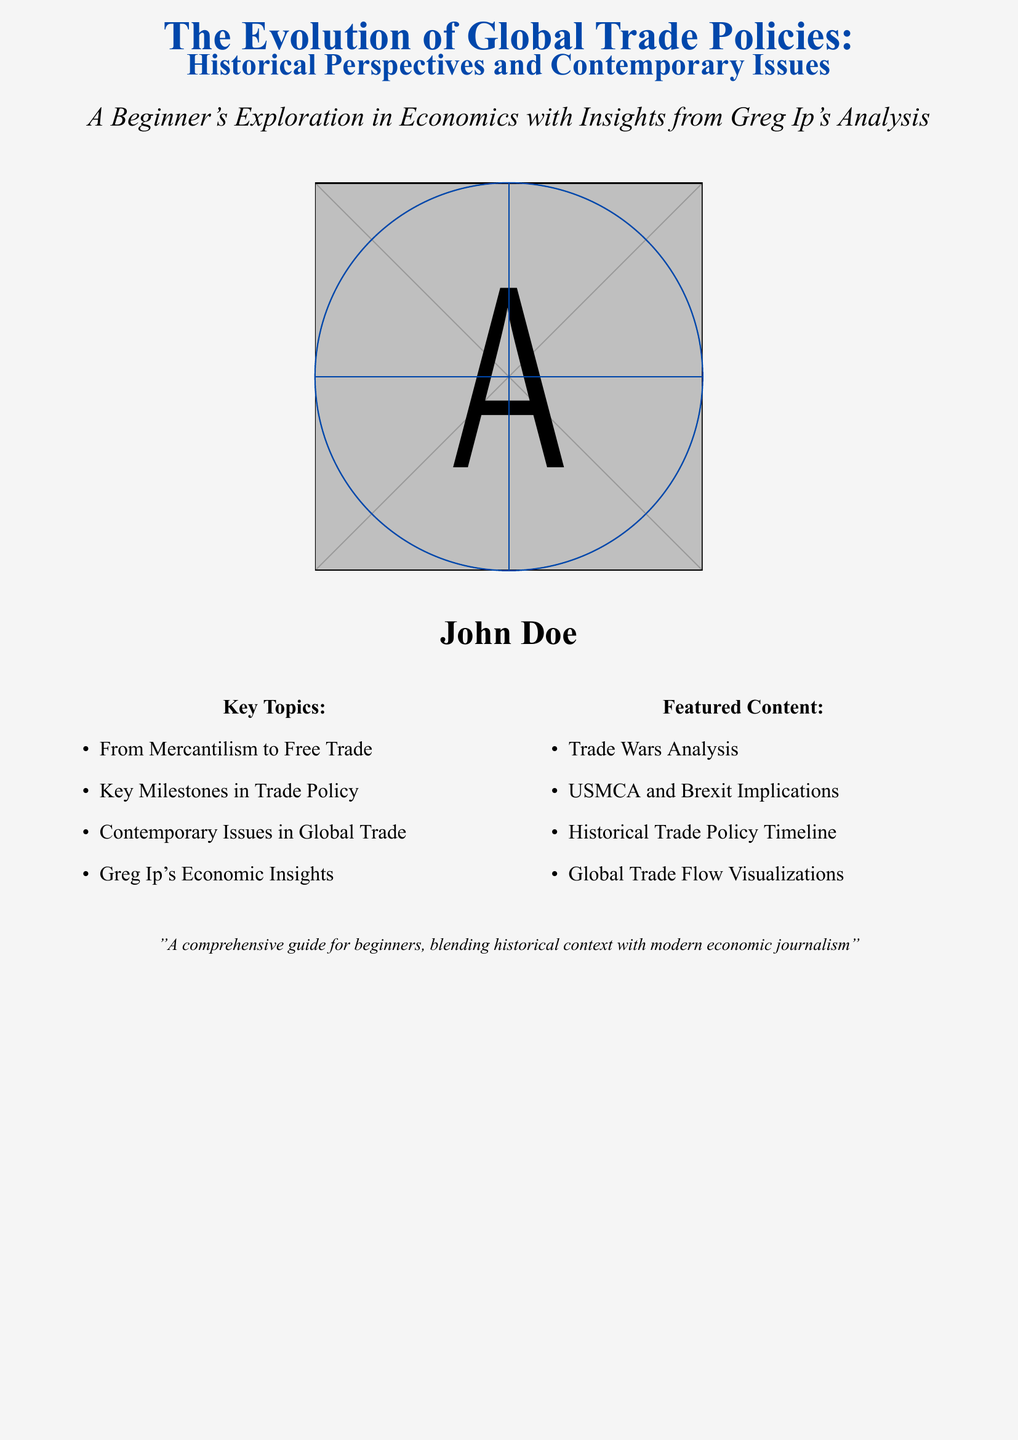What is the title of the book? The title is prominently displayed on the cover in large font.
Answer: The Evolution of Global Trade Policies: Historical Perspectives and Contemporary Issues Who is the author of the book? The author's name is listed towards the bottom of the cover.
Answer: John Doe What key topic relates to trade policy's historical progression? The document outlines key topics in a list format.
Answer: From Mercantilism to Free Trade What is one contemporary issue mentioned in the key topics? Contemporary issues are highlighted in the key topics section.
Answer: Contemporary Issues in Global Trade What visual element is featured on the cover? The cover includes a visual representation.
Answer: A globe Which significant trade agreement is mentioned in the featured content? The featured content lists important topics regarding trade agreements.
Answer: USMCA What are the implications discussed in regard to Brexit? The document mentions Brexit under featured content, pointing to its significance.
Answer: Brexit Implications Which journalist's insights are included in the book? The cover indicates the inclusion of insights from a known economist.
Answer: Greg Ip's Economic Insights 